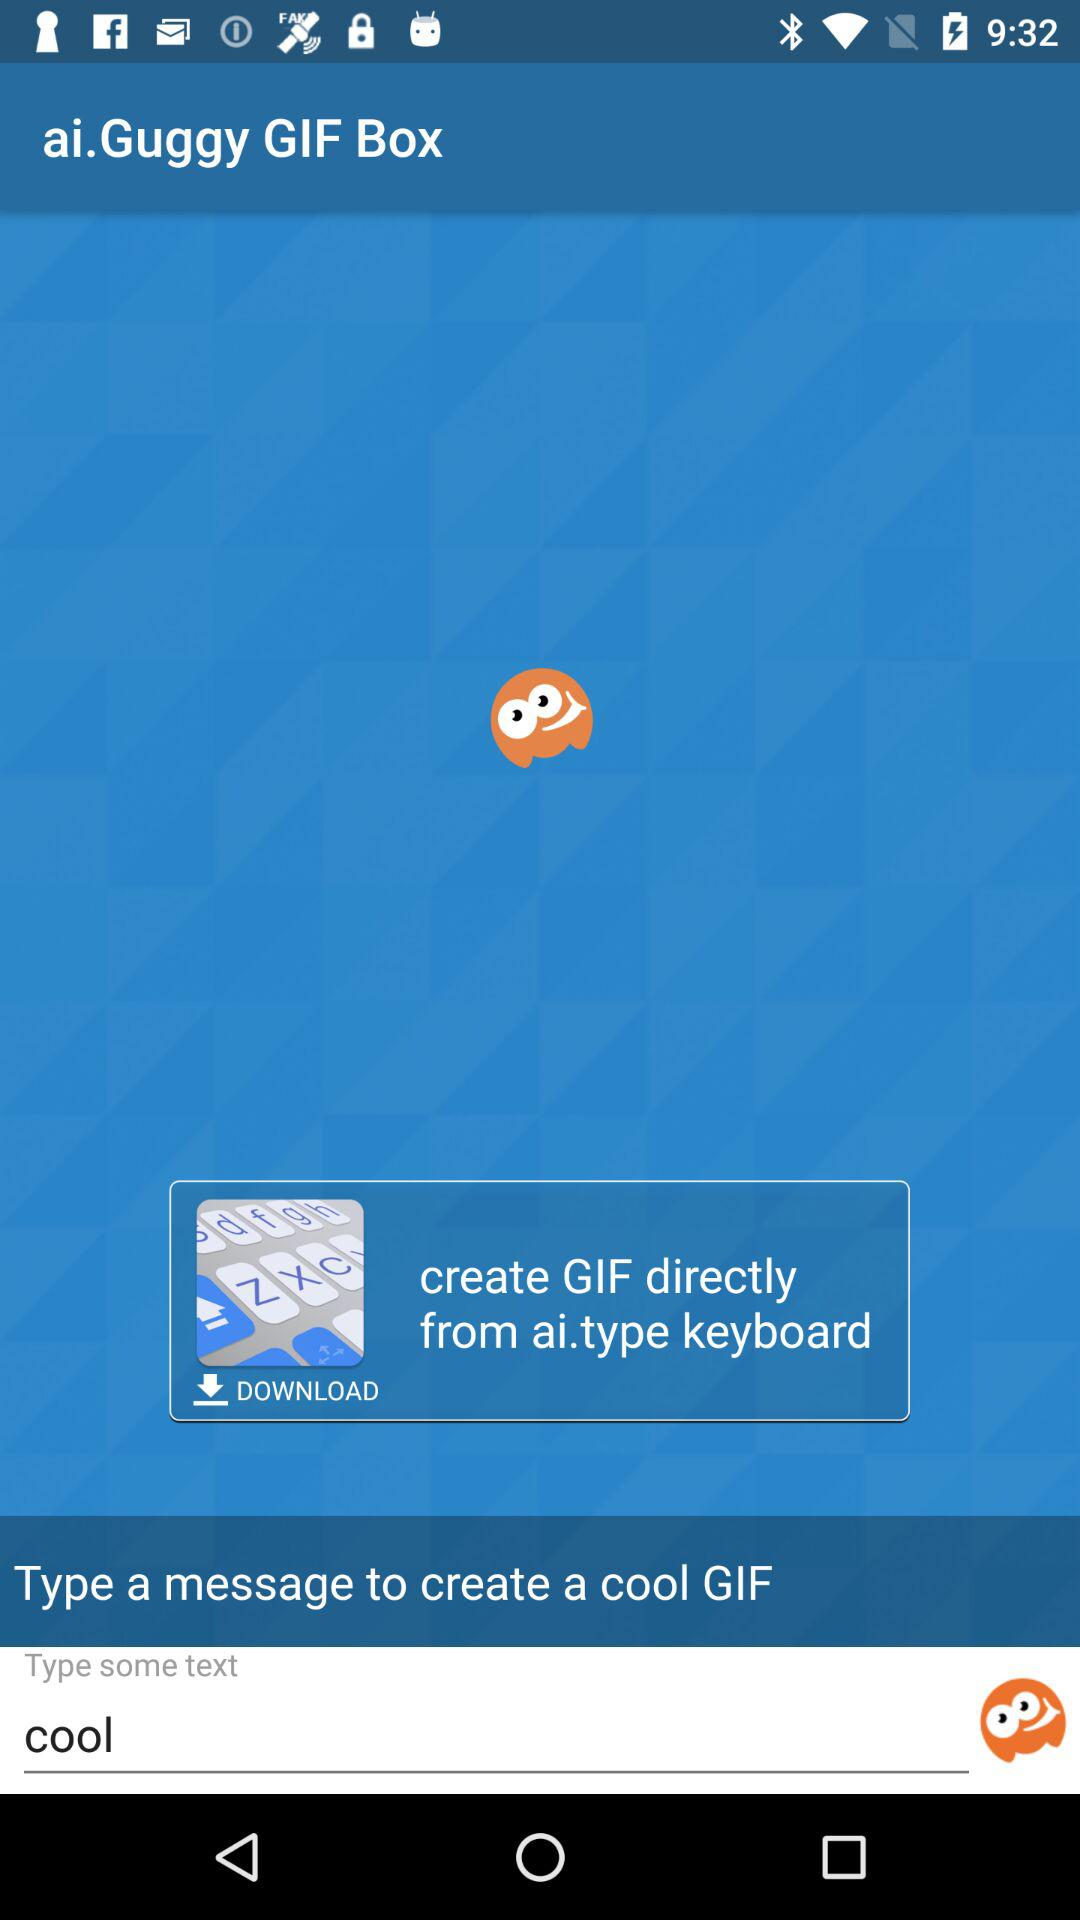What is the text entered in the text box? The text entered in the text box is cool. 